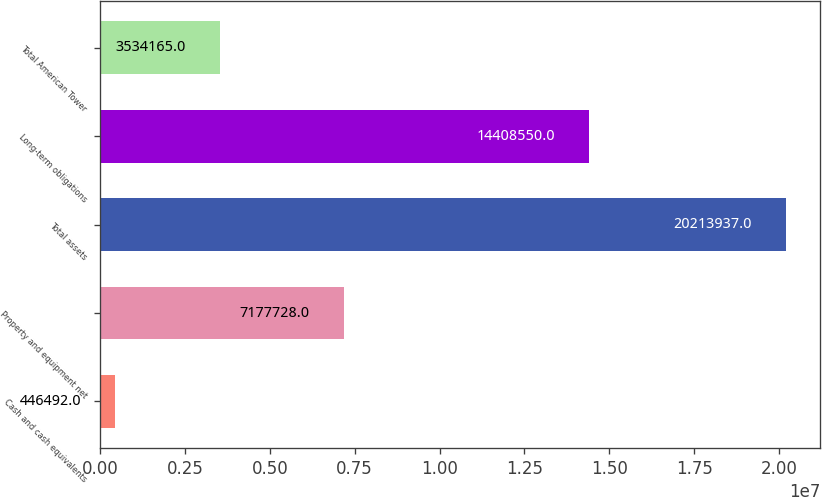Convert chart. <chart><loc_0><loc_0><loc_500><loc_500><bar_chart><fcel>Cash and cash equivalents<fcel>Property and equipment net<fcel>Total assets<fcel>Long-term obligations<fcel>Total American Tower<nl><fcel>446492<fcel>7.17773e+06<fcel>2.02139e+07<fcel>1.44086e+07<fcel>3.53416e+06<nl></chart> 